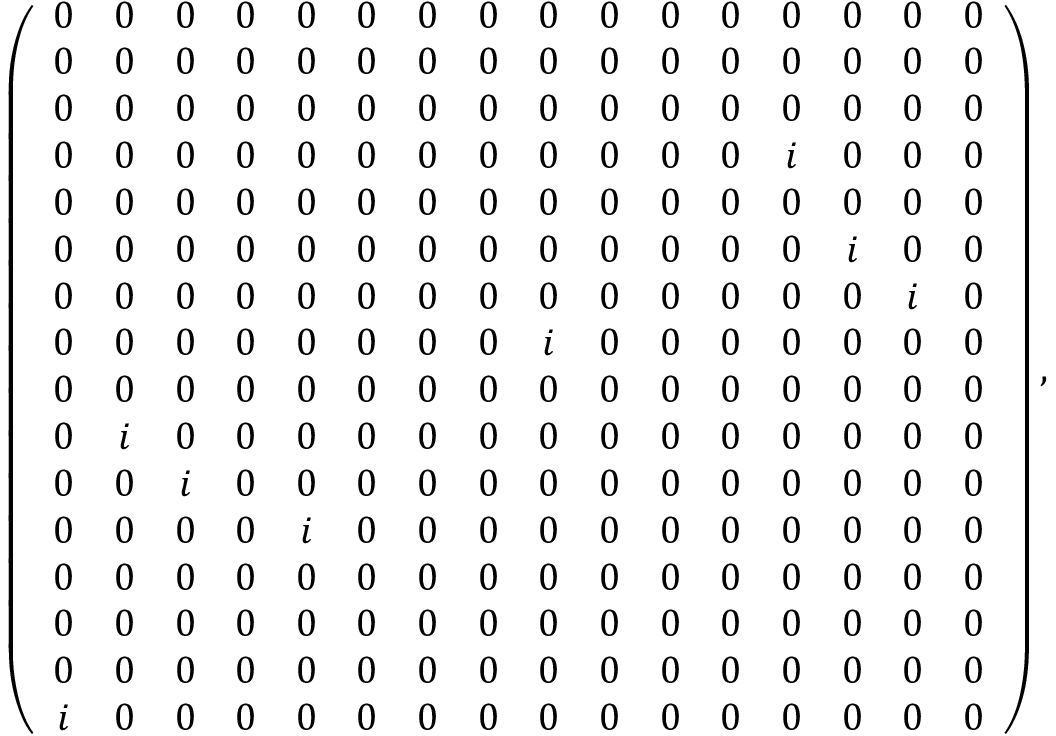<formula> <loc_0><loc_0><loc_500><loc_500>\left ( \begin{array} { c c c c c c c c c c c c c c c c } { 0 } & { 0 } & { 0 } & { 0 } & { 0 } & { 0 } & { 0 } & { 0 } & { 0 } & { 0 } & { 0 } & { 0 } & { 0 } & { 0 } & { 0 } & { 0 } \\ { 0 } & { 0 } & { 0 } & { 0 } & { 0 } & { 0 } & { 0 } & { 0 } & { 0 } & { 0 } & { 0 } & { 0 } & { 0 } & { 0 } & { 0 } & { 0 } \\ { 0 } & { 0 } & { 0 } & { 0 } & { 0 } & { 0 } & { 0 } & { 0 } & { 0 } & { 0 } & { 0 } & { 0 } & { 0 } & { 0 } & { 0 } & { 0 } \\ { 0 } & { 0 } & { 0 } & { 0 } & { 0 } & { 0 } & { 0 } & { 0 } & { 0 } & { 0 } & { 0 } & { 0 } & { i } & { 0 } & { 0 } & { 0 } \\ { 0 } & { 0 } & { 0 } & { 0 } & { 0 } & { 0 } & { 0 } & { 0 } & { 0 } & { 0 } & { 0 } & { 0 } & { 0 } & { 0 } & { 0 } & { 0 } \\ { 0 } & { 0 } & { 0 } & { 0 } & { 0 } & { 0 } & { 0 } & { 0 } & { 0 } & { 0 } & { 0 } & { 0 } & { 0 } & { i } & { 0 } & { 0 } \\ { 0 } & { 0 } & { 0 } & { 0 } & { 0 } & { 0 } & { 0 } & { 0 } & { 0 } & { 0 } & { 0 } & { 0 } & { 0 } & { 0 } & { i } & { 0 } \\ { 0 } & { 0 } & { 0 } & { 0 } & { 0 } & { 0 } & { 0 } & { 0 } & { i } & { 0 } & { 0 } & { 0 } & { 0 } & { 0 } & { 0 } & { 0 } \\ { 0 } & { 0 } & { 0 } & { 0 } & { 0 } & { 0 } & { 0 } & { 0 } & { 0 } & { 0 } & { 0 } & { 0 } & { 0 } & { 0 } & { 0 } & { 0 } \\ { 0 } & { i } & { 0 } & { 0 } & { 0 } & { 0 } & { 0 } & { 0 } & { 0 } & { 0 } & { 0 } & { 0 } & { 0 } & { 0 } & { 0 } & { 0 } \\ { 0 } & { 0 } & { i } & { 0 } & { 0 } & { 0 } & { 0 } & { 0 } & { 0 } & { 0 } & { 0 } & { 0 } & { 0 } & { 0 } & { 0 } & { 0 } \\ { 0 } & { 0 } & { 0 } & { 0 } & { i } & { 0 } & { 0 } & { 0 } & { 0 } & { 0 } & { 0 } & { 0 } & { 0 } & { 0 } & { 0 } & { 0 } \\ { 0 } & { 0 } & { 0 } & { 0 } & { 0 } & { 0 } & { 0 } & { 0 } & { 0 } & { 0 } & { 0 } & { 0 } & { 0 } & { 0 } & { 0 } & { 0 } \\ { 0 } & { 0 } & { 0 } & { 0 } & { 0 } & { 0 } & { 0 } & { 0 } & { 0 } & { 0 } & { 0 } & { 0 } & { 0 } & { 0 } & { 0 } & { 0 } \\ { 0 } & { 0 } & { 0 } & { 0 } & { 0 } & { 0 } & { 0 } & { 0 } & { 0 } & { 0 } & { 0 } & { 0 } & { 0 } & { 0 } & { 0 } & { 0 } \\ { i } & { 0 } & { 0 } & { 0 } & { 0 } & { 0 } & { 0 } & { 0 } & { 0 } & { 0 } & { 0 } & { 0 } & { 0 } & { 0 } & { 0 } & { 0 } \end{array} \right ) ,</formula> 